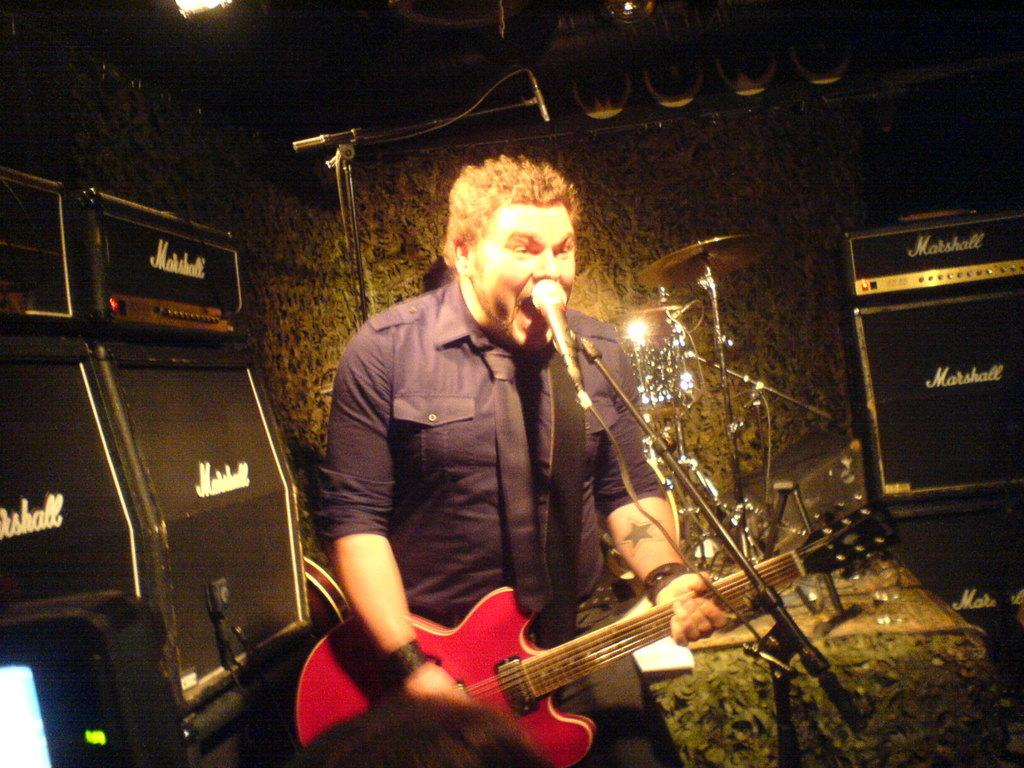Who is the main subject in the image? There is a man in the image. What is the man doing in the image? The man is standing and holding a guitar. What object is in front of the man? There is a microphone in front of the man. Can you describe the background of the image? There are additional microphones and speakers in the background. What type of lumber is the man using to play the guitar in the image? There is no lumber present in the image, and the guitar is not made of lumber. 